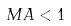Convert formula to latex. <formula><loc_0><loc_0><loc_500><loc_500>M A < 1</formula> 